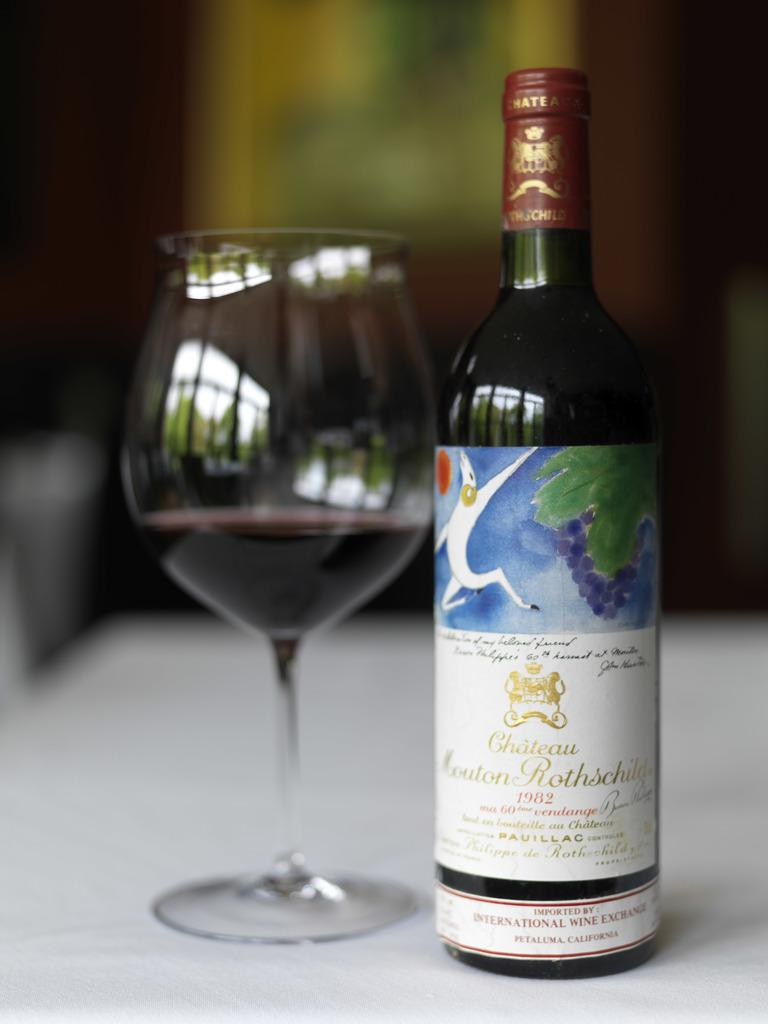What type of beverage container is present in the image? There is a wine bottle in the image. What is used for drinking the beverage in the image? There is a wine glass in the image. Where are the wine bottle and wine glass located? The wine bottle and wine glass are on a table. Can you tell me how many tigers are present in the image? There are no tigers present in the image; it only features a wine bottle and wine glass on a table. What type of flower is depicted on the wine bottle in the image? There is no flower depicted on the wine bottle in the image; it is a plain wine bottle. 